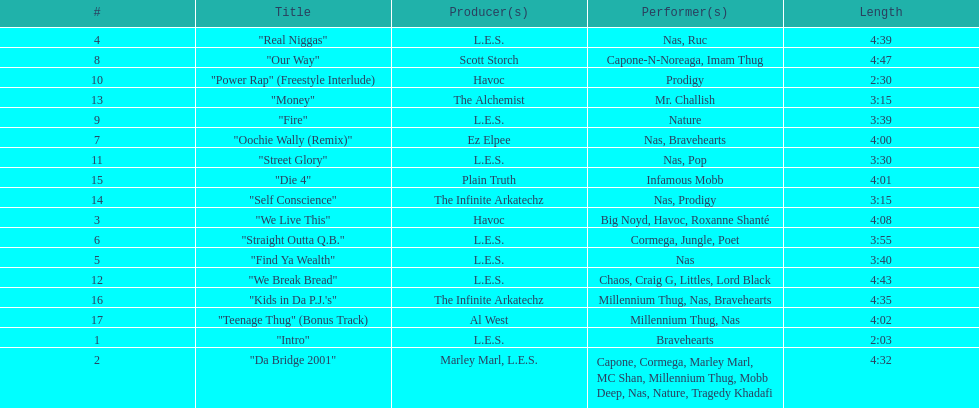How long is the longest track listed? 4:47. 